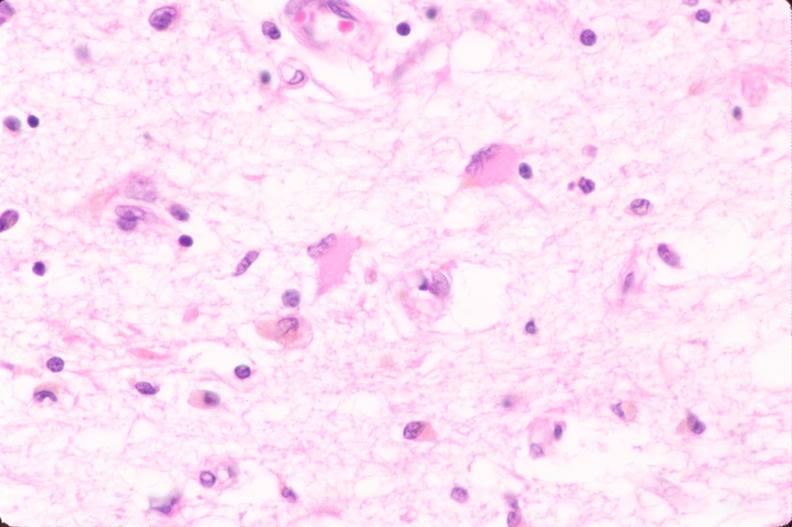s respiratory present?
Answer the question using a single word or phrase. Yes 